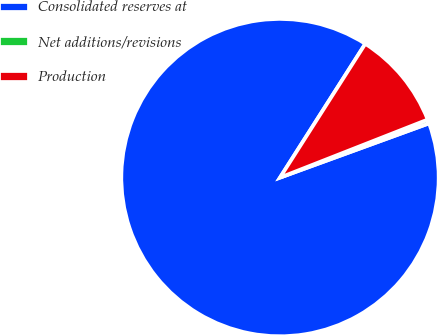Convert chart to OTSL. <chart><loc_0><loc_0><loc_500><loc_500><pie_chart><fcel>Consolidated reserves at<fcel>Net additions/revisions<fcel>Production<nl><fcel>89.59%<fcel>0.4%<fcel>10.01%<nl></chart> 